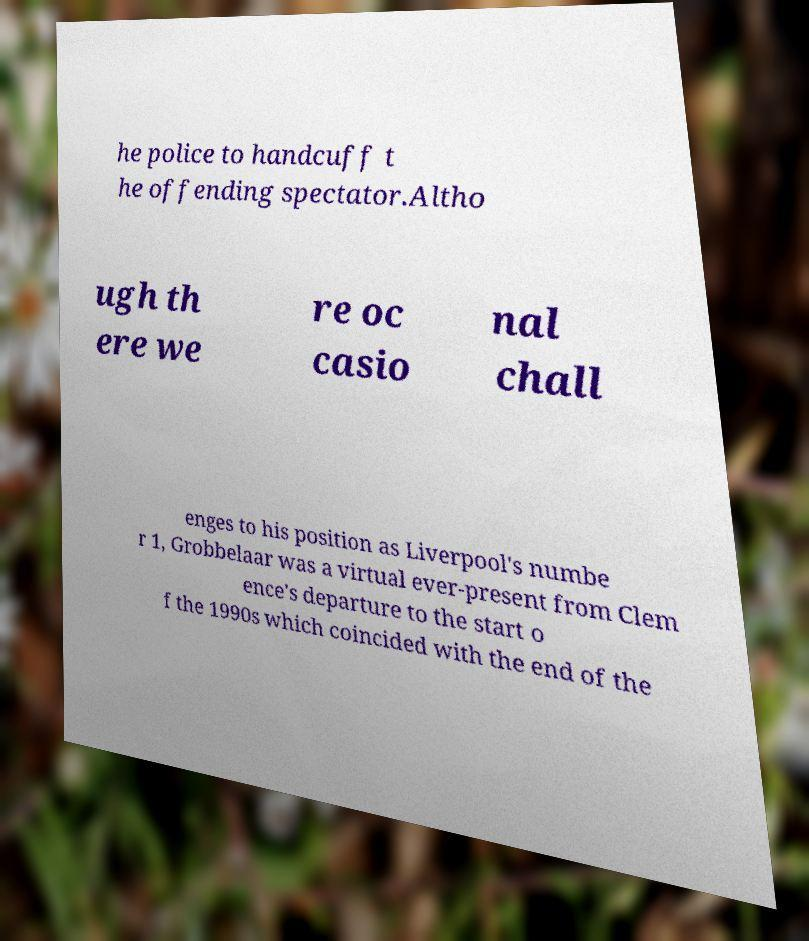There's text embedded in this image that I need extracted. Can you transcribe it verbatim? he police to handcuff t he offending spectator.Altho ugh th ere we re oc casio nal chall enges to his position as Liverpool's numbe r 1, Grobbelaar was a virtual ever-present from Clem ence's departure to the start o f the 1990s which coincided with the end of the 